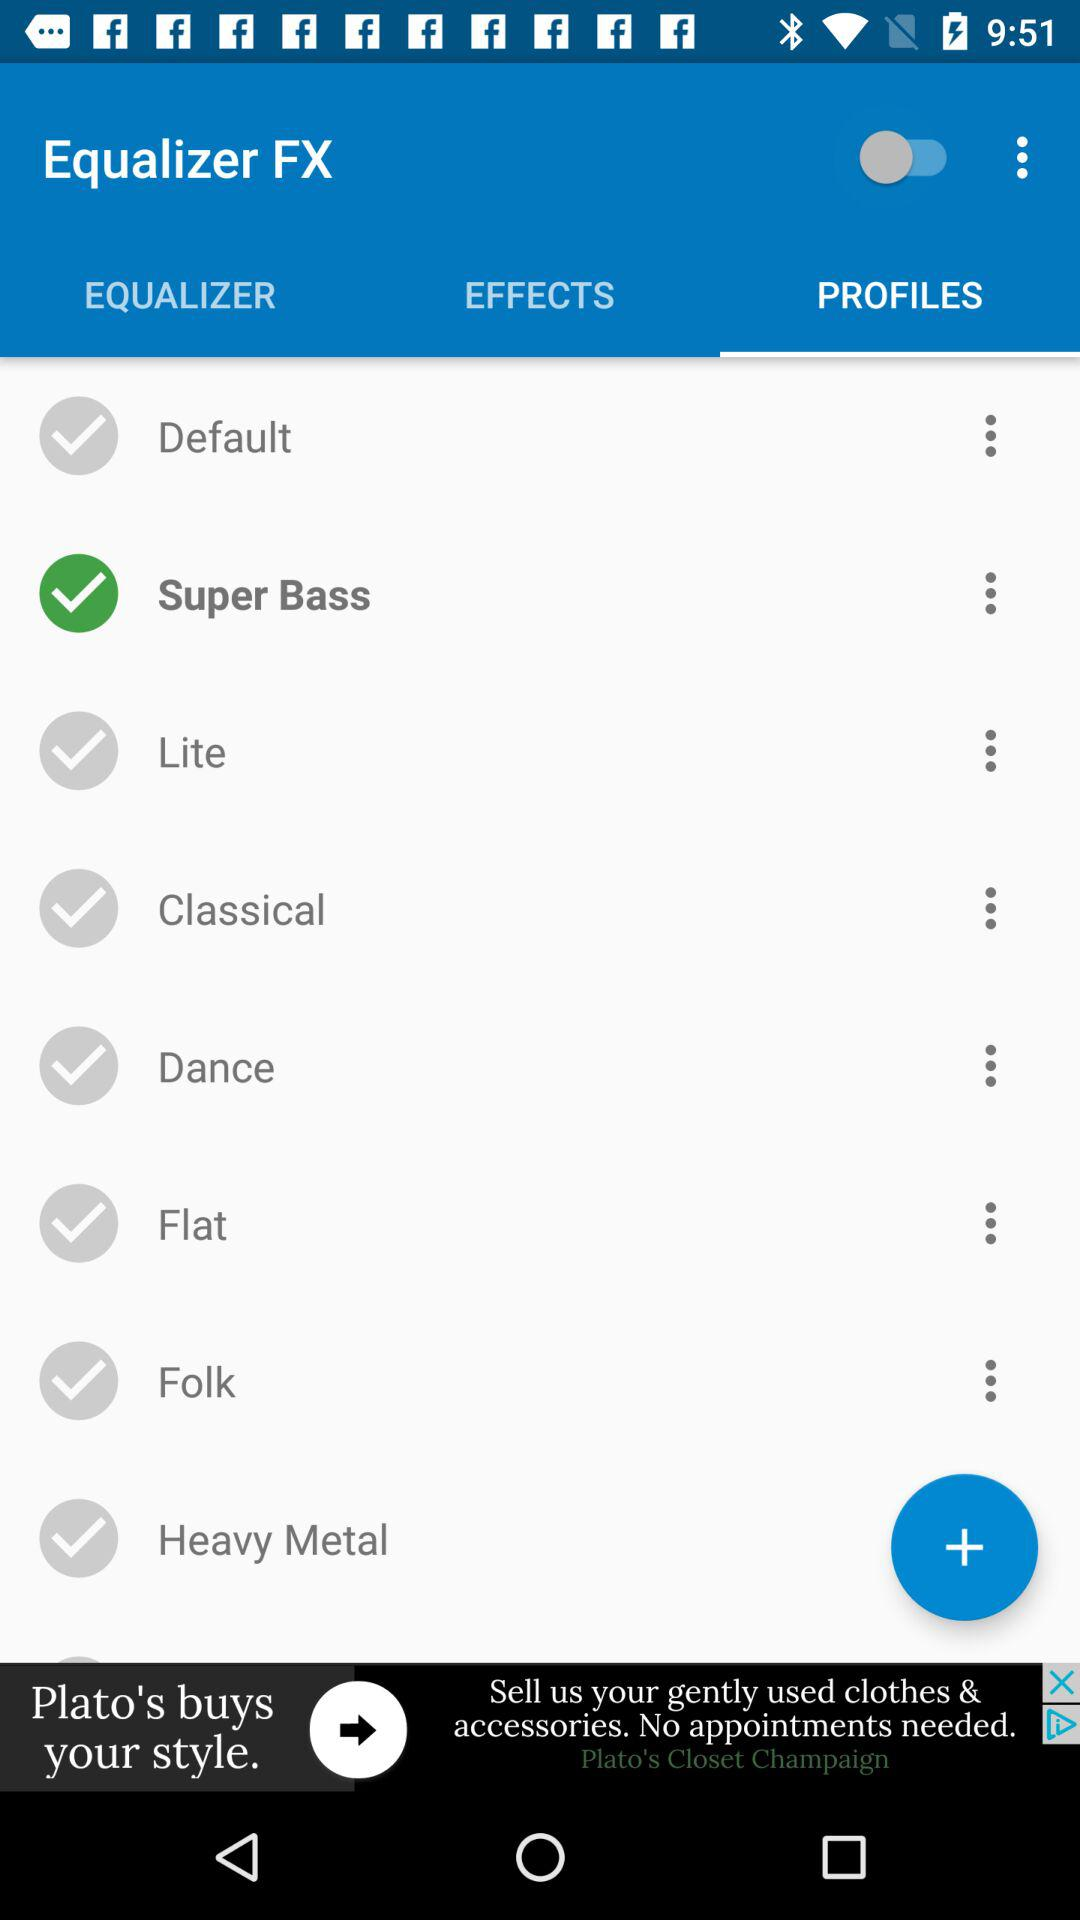How many equalizer presets are there?
Answer the question using a single word or phrase. 8 